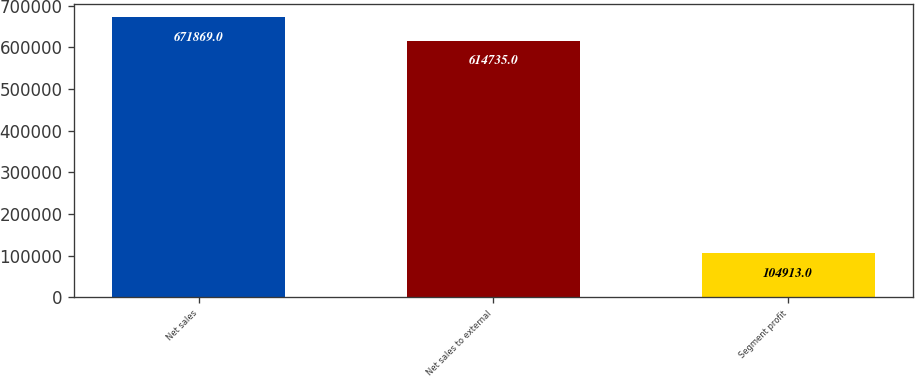Convert chart. <chart><loc_0><loc_0><loc_500><loc_500><bar_chart><fcel>Net sales<fcel>Net sales to external<fcel>Segment profit<nl><fcel>671869<fcel>614735<fcel>104913<nl></chart> 